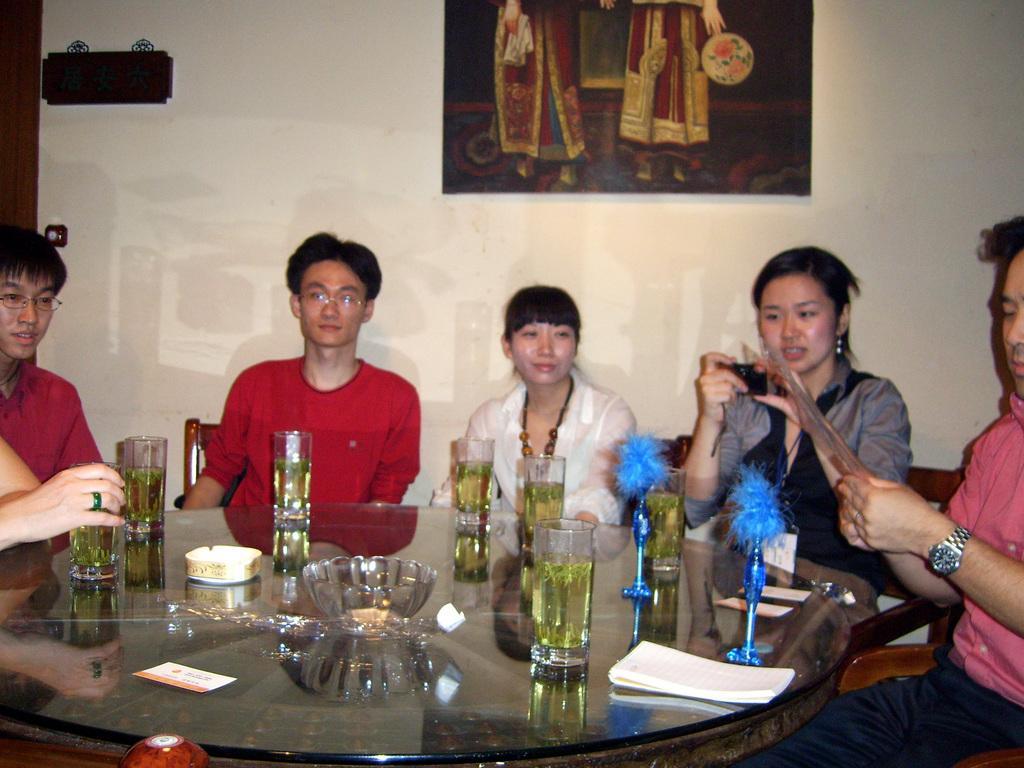In one or two sentences, can you explain what this image depicts? It looks like a party there is a glass table, there are some glasses on the table with drinks and also a bowl,group of people are sitting around the table in the background there is a cream color wall and some posters stick to the wall. 